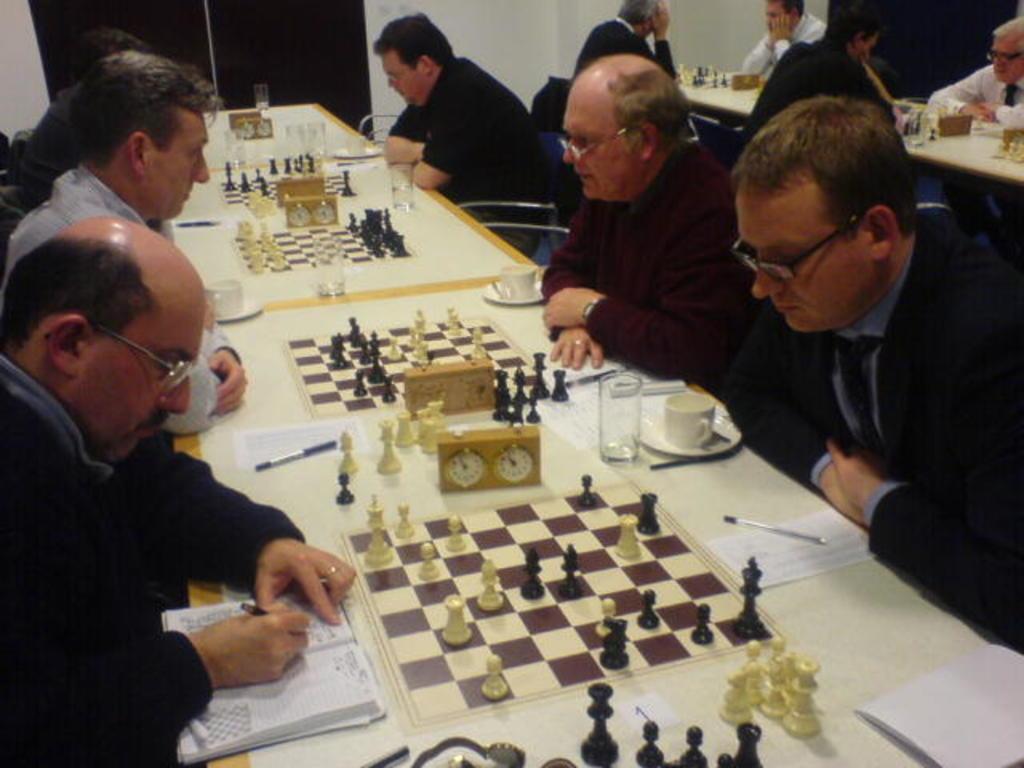Describe this image in one or two sentences. In this picture we can see there are groups of people. In front of the people, there are tables and on the tables there are chess boards, chess pieces, glasses, cups, saucers, papers, pens, a book and some objects. Behind the people, there is a wall. 